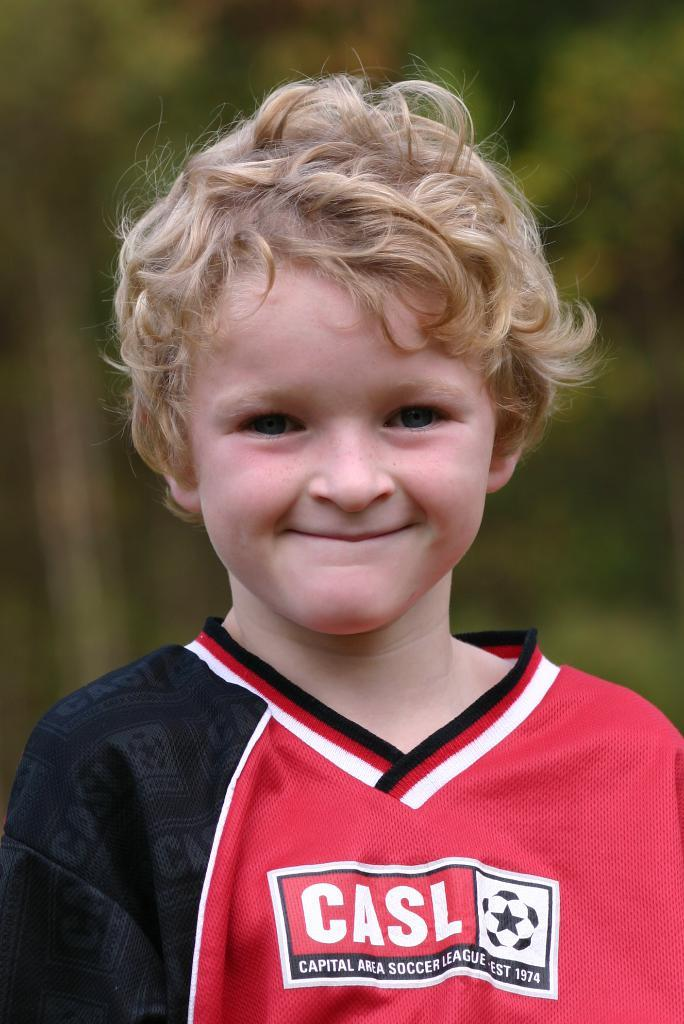Provide a one-sentence caption for the provided image. a boy that has the word casl on his soccer jersey. 